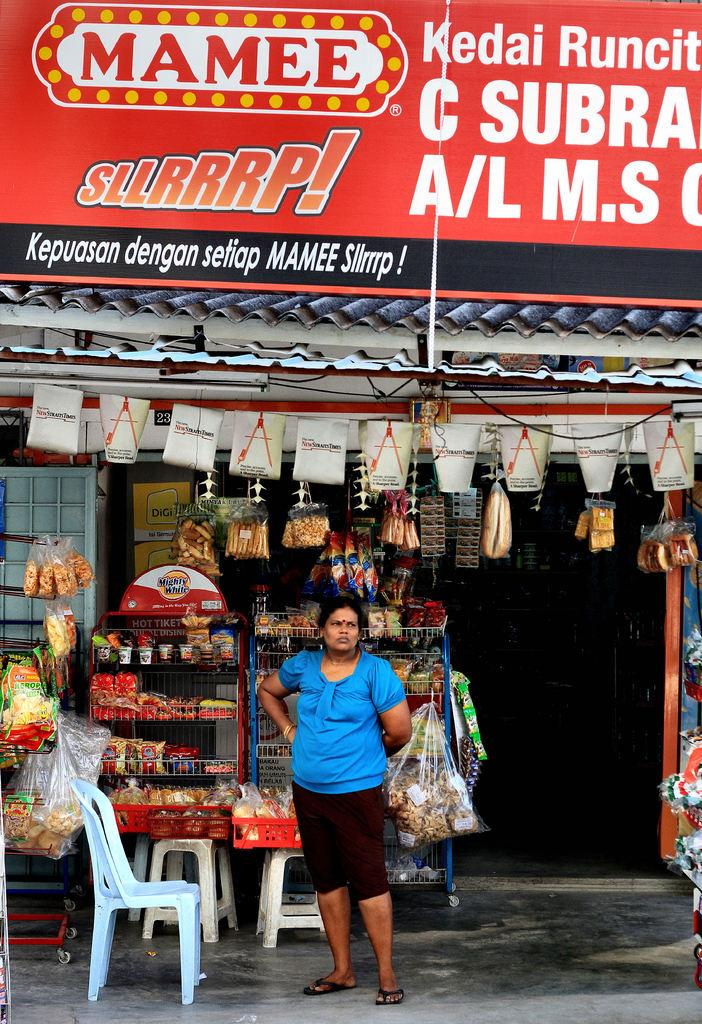Who is present in the image? There is a woman in the image. What is the woman wearing? The woman is wearing a blue top. Where is the woman standing in the image? The woman is standing in front of a shop. What type of seating is visible in the image? There are stools and chairs in the image. What type of business is being conducted in the image? The image does not show any business being conducted; it only shows a woman standing in front of a shop. What toys can be seen in the image? There are no toys present in the image. 